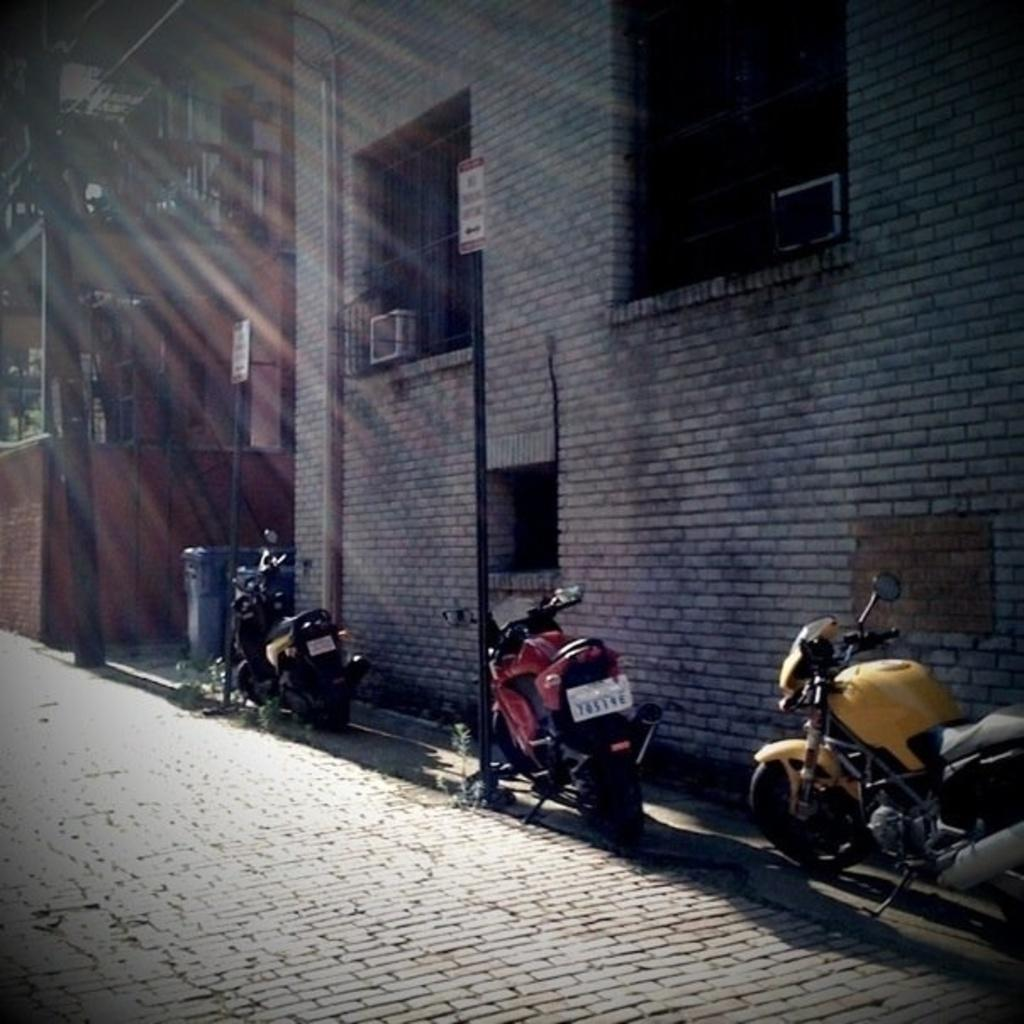How many buildings can be seen in the image? There are two buildings in the image. What are the colors of the buildings? One building is red in color, and the other building is grey in color. What else can be seen in the image besides the buildings? There are poles, bikes, and a lane visible in the image. Are there any cherries growing on the poles in the image? There are no cherries visible in the image, and there is no indication that the poles are related to cherry growth. 